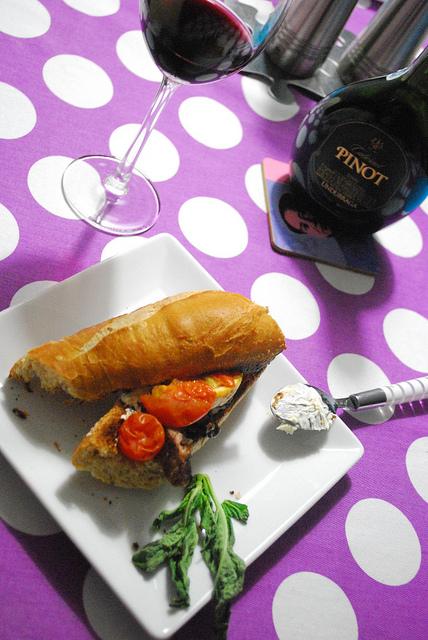What kind of wine is served here?
Write a very short answer. Pinot. What type of meal is on the plate?
Answer briefly. Lunch. What color is the wine?
Concise answer only. Red. 